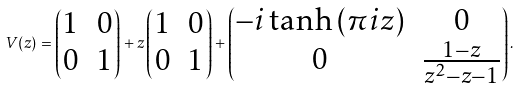<formula> <loc_0><loc_0><loc_500><loc_500>V ( z ) = \begin{pmatrix} 1 & 0 \\ 0 & 1 \end{pmatrix} + z \begin{pmatrix} 1 & 0 \\ 0 & 1 \end{pmatrix} + \begin{pmatrix} - i \tanh \left ( \pi i z \right ) & 0 \\ 0 & \frac { 1 - z } { z ^ { 2 } - z - 1 } \end{pmatrix} .</formula> 